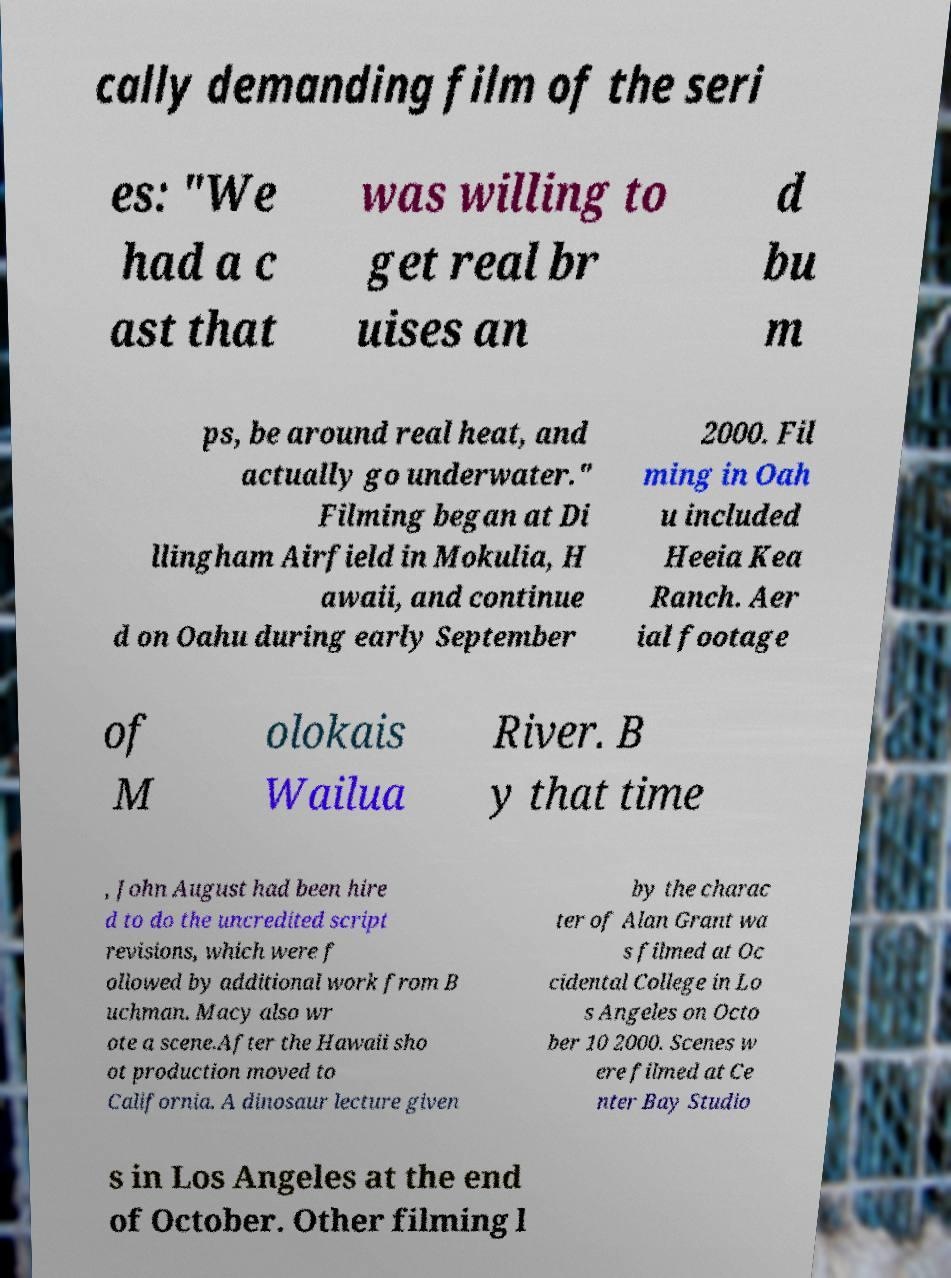Please identify and transcribe the text found in this image. cally demanding film of the seri es: "We had a c ast that was willing to get real br uises an d bu m ps, be around real heat, and actually go underwater." Filming began at Di llingham Airfield in Mokulia, H awaii, and continue d on Oahu during early September 2000. Fil ming in Oah u included Heeia Kea Ranch. Aer ial footage of M olokais Wailua River. B y that time , John August had been hire d to do the uncredited script revisions, which were f ollowed by additional work from B uchman. Macy also wr ote a scene.After the Hawaii sho ot production moved to California. A dinosaur lecture given by the charac ter of Alan Grant wa s filmed at Oc cidental College in Lo s Angeles on Octo ber 10 2000. Scenes w ere filmed at Ce nter Bay Studio s in Los Angeles at the end of October. Other filming l 